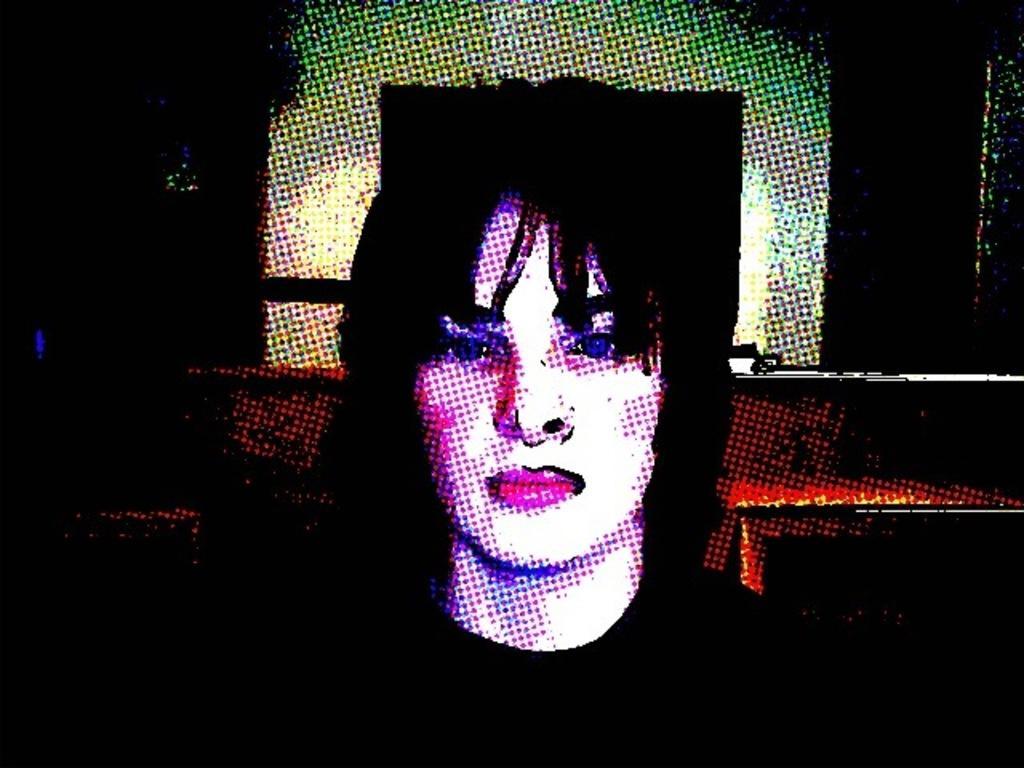How would you summarize this image in a sentence or two? This is an edited image, we can see a person and behind the person there is a dark background. 